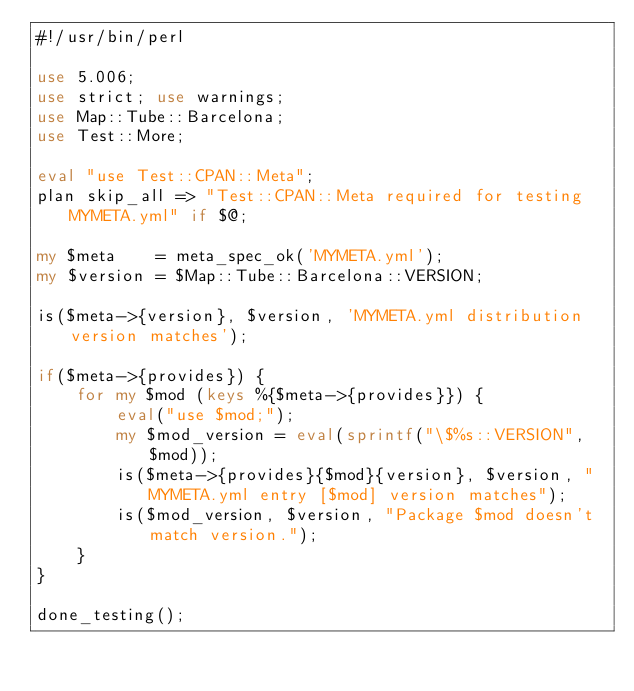Convert code to text. <code><loc_0><loc_0><loc_500><loc_500><_Perl_>#!/usr/bin/perl

use 5.006;
use strict; use warnings;
use Map::Tube::Barcelona;
use Test::More;

eval "use Test::CPAN::Meta";
plan skip_all => "Test::CPAN::Meta required for testing MYMETA.yml" if $@;

my $meta    = meta_spec_ok('MYMETA.yml');
my $version = $Map::Tube::Barcelona::VERSION;

is($meta->{version}, $version, 'MYMETA.yml distribution version matches');

if($meta->{provides}) {
    for my $mod (keys %{$meta->{provides}}) {
        eval("use $mod;");
        my $mod_version = eval(sprintf("\$%s::VERSION", $mod));
        is($meta->{provides}{$mod}{version}, $version, "MYMETA.yml entry [$mod] version matches");
        is($mod_version, $version, "Package $mod doesn't match version.");
    }
}

done_testing();
</code> 